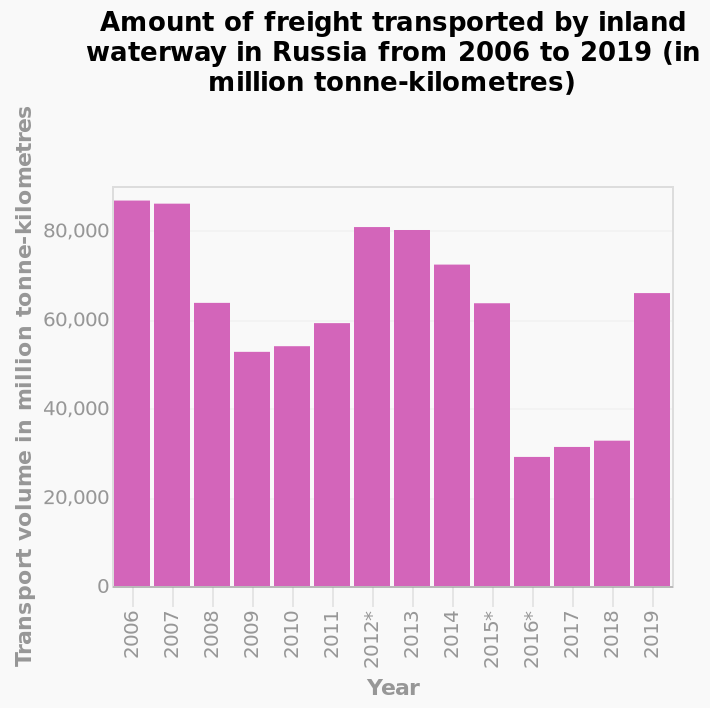<image>
What does the y-axis plot in the bar diagram?  The y-axis plots Transport volume in million tonne-kilometres. 